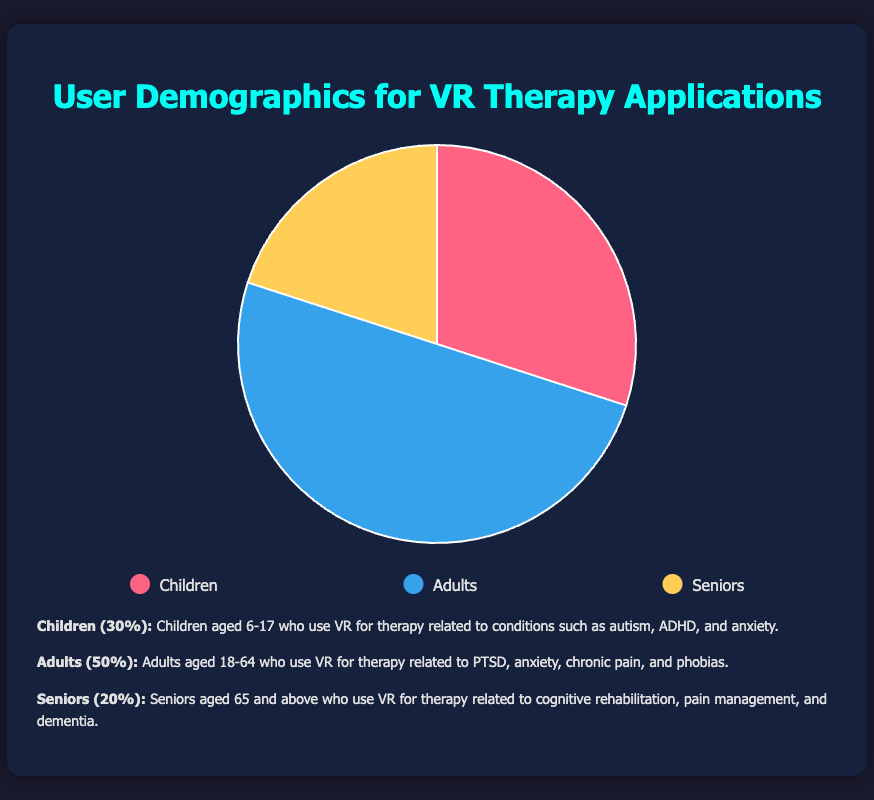What percentage of VR therapy users are children? To find the percentage of VR therapy users who are children, refer to the segment labeled "Children" in the pie chart. The description indicates that children make up 30% of the total user base.
Answer: 30% Which user group has the highest percentage in VR therapy applications? By examining the pie chart, the largest segment corresponds to adults, which is indicated to be 50%. This is the highest among the three groups.
Answer: Adults What is the combined percentage of children and seniors using VR therapy? The percentage of children is 30% and the percentage of seniors is 20%. Summing these two percentages together: 30% + 20% = 50%.
Answer: 50% What is the difference in percentage between adults and seniors using VR therapy? To find the difference in usage between adults and seniors, subtract the seniors' percentage from the adults' percentage: 50% (adults) - 20% (seniors) = 30%.
Answer: 30% Which color represents the adult user group in the pie chart? According to the legend, the adult user group is represented by the blue color in the pie chart.
Answer: Blue How many times larger is the percentage of adults than the percentage of seniors? To determine how many times larger the percentage of adults is compared to seniors, divide the adults' percentage by the seniors' percentage: 50% / 20% = 2.5.
Answer: 2.5 times What is the ratio of children to total users in VR therapy? The percentage of children is 30%. The ratio is calculated by taking the percentage of children relative to the total percentage, which is 30% out of 100% in total. Thus, the ratio is 30:100, simplified to 3:10.
Answer: 3:10 How does the percentage of children compare to the percentage of seniors using VR therapy? By comparing the percentages directly, children make up 30% and seniors make up 20%. Thus, the percentage of children is higher than that of seniors.
Answer: Higher If you combine the percentages of children and adults, how much of the total VR therapy user base do they represent? To find the combined percentage of children and adults, add their percentages together: 30% (children) + 50% (adults) = 80%.
Answer: 80% What cognitive conditions might seniors be using VR therapy for? According to the description provided, seniors aged 65 and above use VR for therapy related to cognitive rehabilitation, pain management, and dementia.
Answer: Cognitive rehabilitation, pain management, and dementia 